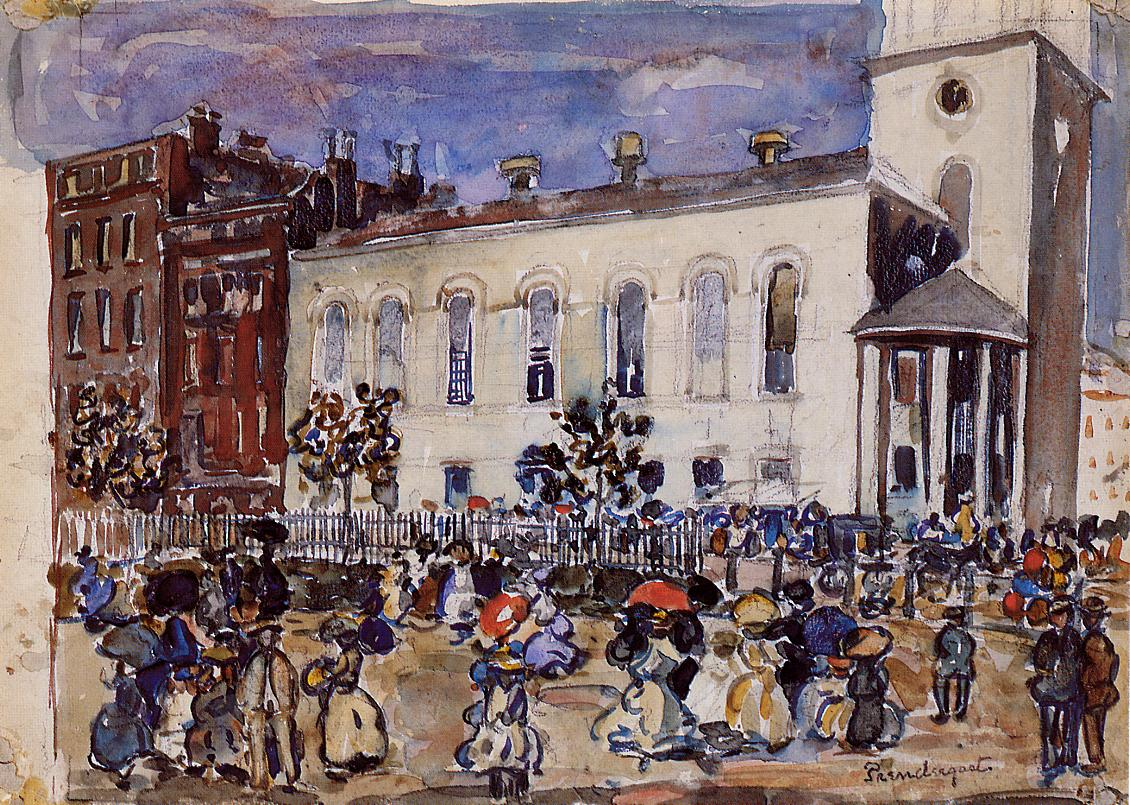Can you discuss the social aspects depicted in this street scene? This painting captures a slice of social life from an era suggestive of the early 20th century. It shows a diverse array of individuals engaged in daily activities, highlighting social interactions like conversations, trading, and children at play. The mix of classes suggested by varying attires, from more formal coats and hats to simpler, working-class garments, reflects the social dynamics of the time, offering a window into the historical social fabric. How does the architectural style contribute to the painting's overall mood? The architecture, characterized by Classical motifs, exudes a sense of stability and order. Its robust and enduring presence contrasts sharply with the transient, fluid motion of the people and street activities, thus adding a poignant backdrop that enhances the emotional depth of the scene. The stark whites and structured lines of the buildings also serve as a visual anchor in the lively, somewhat chaotic street life. 